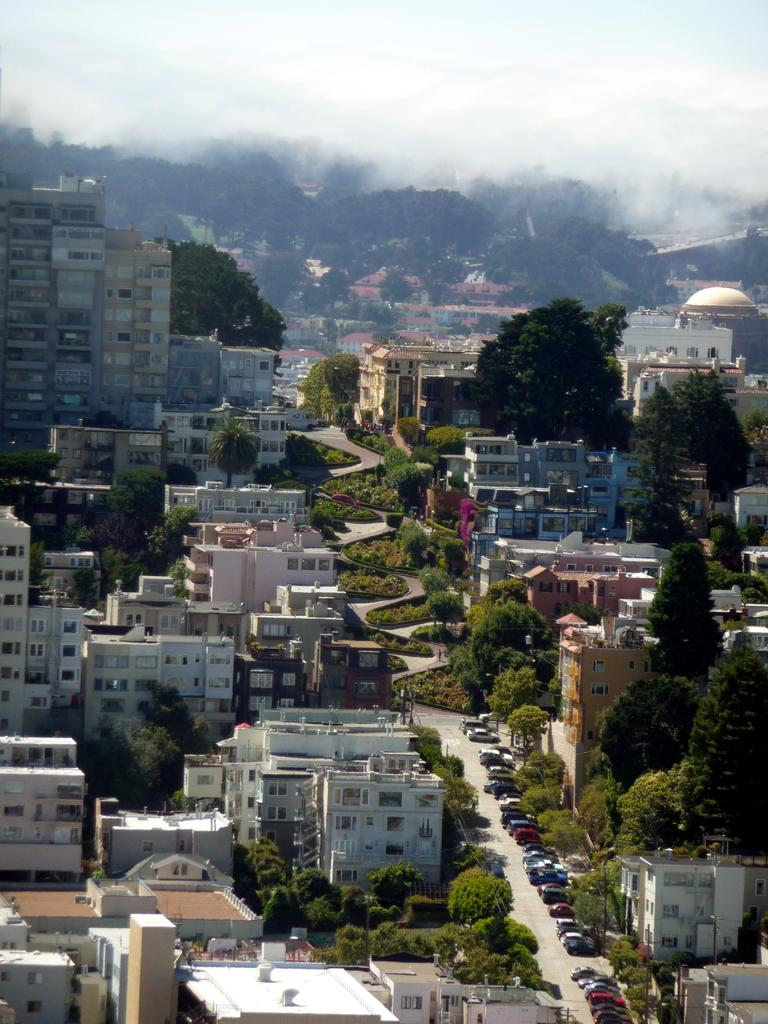What type of structures can be seen in the image? There are buildings in the image. What type of vegetation is present in the image? There are trees, grass, and plants in the image. What vehicles can be seen on the right side of the image? There are cars on the right side of the image. What is the weather condition in the image? There is fog visible in the background of the image, which suggests a foggy condition. What is visible at the top of the image? The sky is visible at the top of the image. Can you tell me how many gallons of oil are stored in the building on the left side of the image? There is no information about oil storage in the building on the left side of the image. What type of wing is visible on the right side of the image? There is no wing visible on the right side of the image. 